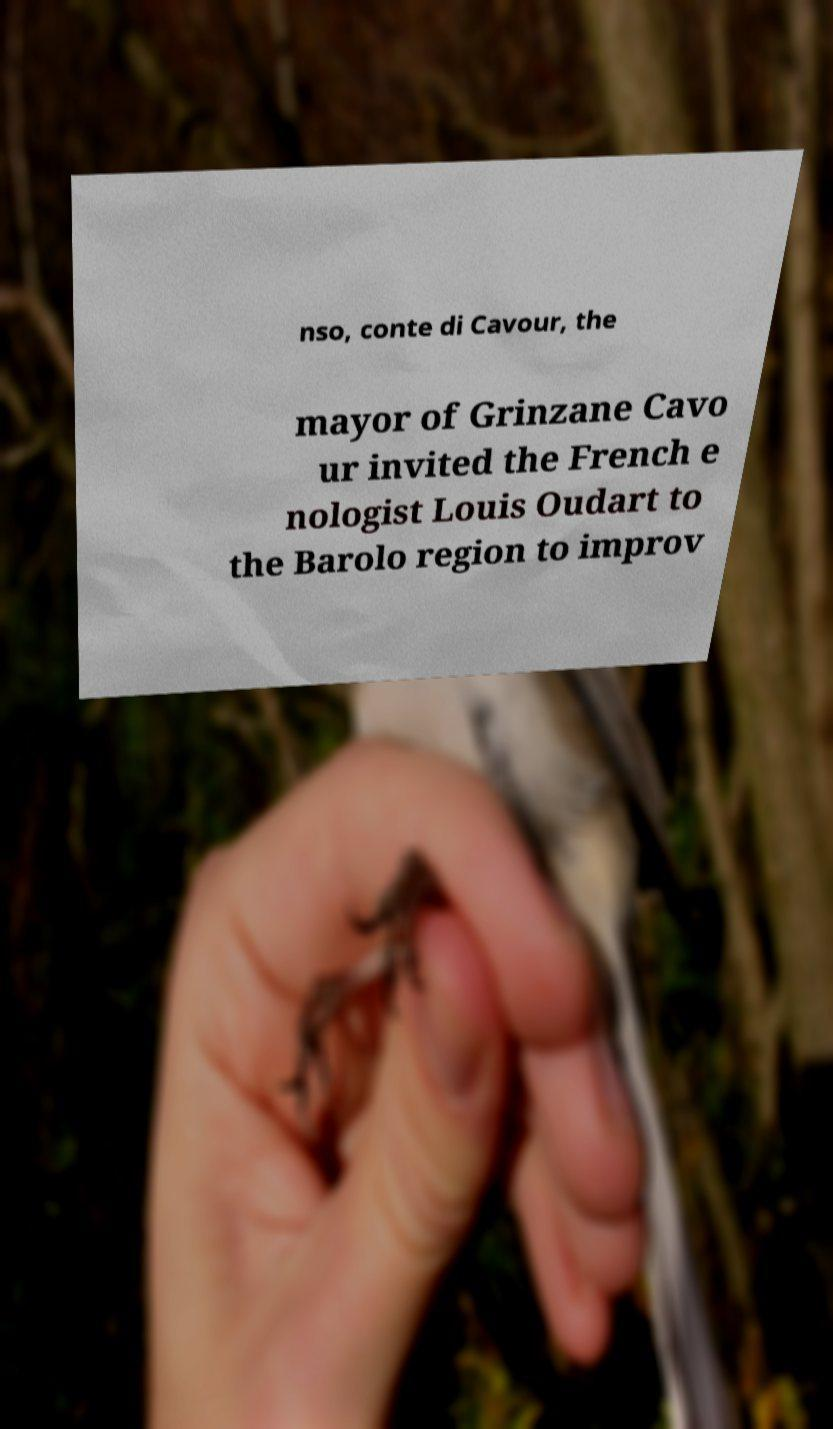Could you extract and type out the text from this image? nso, conte di Cavour, the mayor of Grinzane Cavo ur invited the French e nologist Louis Oudart to the Barolo region to improv 